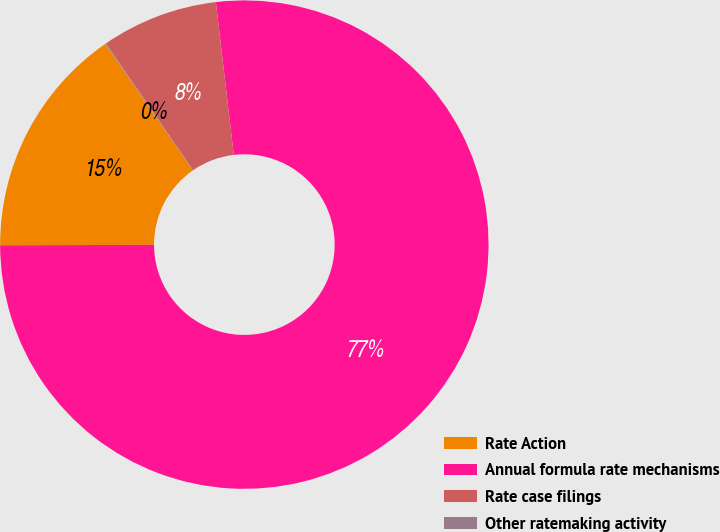<chart> <loc_0><loc_0><loc_500><loc_500><pie_chart><fcel>Rate Action<fcel>Annual formula rate mechanisms<fcel>Rate case filings<fcel>Other ratemaking activity<nl><fcel>15.4%<fcel>76.81%<fcel>7.73%<fcel>0.05%<nl></chart> 